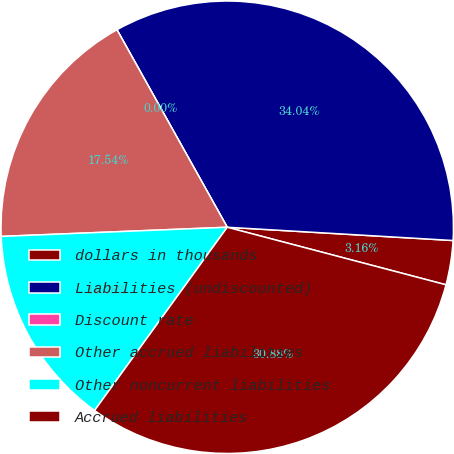Convert chart. <chart><loc_0><loc_0><loc_500><loc_500><pie_chart><fcel>dollars in thousands<fcel>Liabilities (undiscounted)<fcel>Discount rate<fcel>Other accrued liabilities<fcel>Other noncurrent liabilities<fcel>Accrued liabilities<nl><fcel>3.16%<fcel>34.04%<fcel>0.0%<fcel>17.54%<fcel>14.38%<fcel>30.88%<nl></chart> 